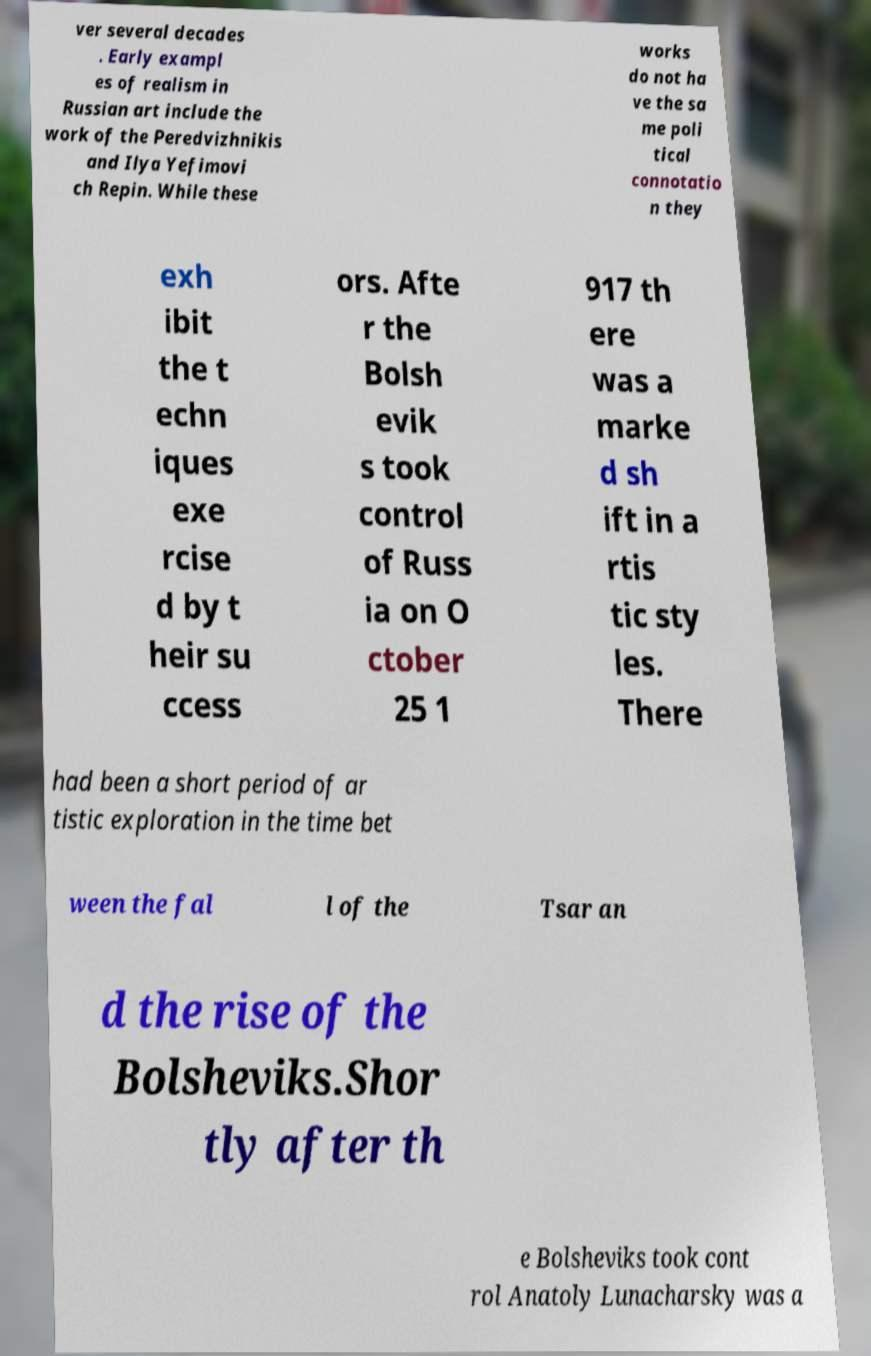Could you extract and type out the text from this image? ver several decades . Early exampl es of realism in Russian art include the work of the Peredvizhnikis and Ilya Yefimovi ch Repin. While these works do not ha ve the sa me poli tical connotatio n they exh ibit the t echn iques exe rcise d by t heir su ccess ors. Afte r the Bolsh evik s took control of Russ ia on O ctober 25 1 917 th ere was a marke d sh ift in a rtis tic sty les. There had been a short period of ar tistic exploration in the time bet ween the fal l of the Tsar an d the rise of the Bolsheviks.Shor tly after th e Bolsheviks took cont rol Anatoly Lunacharsky was a 